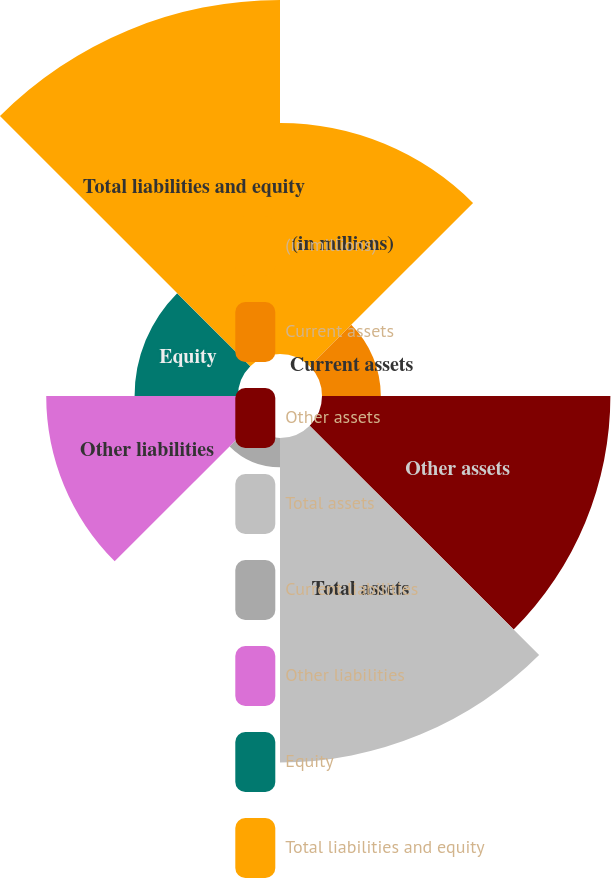Convert chart. <chart><loc_0><loc_0><loc_500><loc_500><pie_chart><fcel>(in millions)<fcel>Current assets<fcel>Other assets<fcel>Total assets<fcel>Current liabilities<fcel>Other liabilities<fcel>Equity<fcel>Total liabilities and equity<nl><fcel>14.61%<fcel>3.72%<fcel>18.24%<fcel>20.52%<fcel>1.85%<fcel>12.13%<fcel>6.54%<fcel>22.39%<nl></chart> 